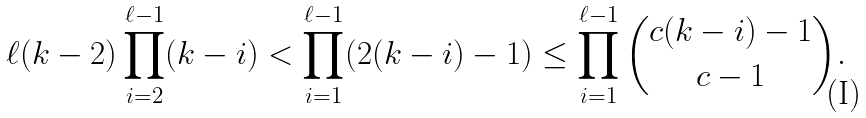<formula> <loc_0><loc_0><loc_500><loc_500>\ell ( k - 2 ) \prod _ { i = 2 } ^ { \ell - 1 } ( k - i ) < \prod _ { i = 1 } ^ { \ell - 1 } ( 2 ( k - i ) - 1 ) \leq \prod _ { i = 1 } ^ { \ell - 1 } { c ( k - i ) - 1 \choose c - 1 } .</formula> 